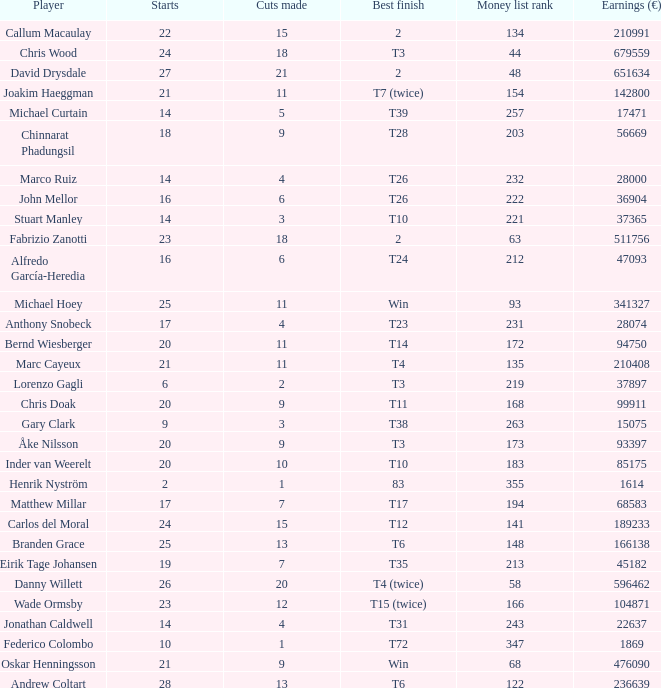Which player made exactly 26 starts? Danny Willett. 